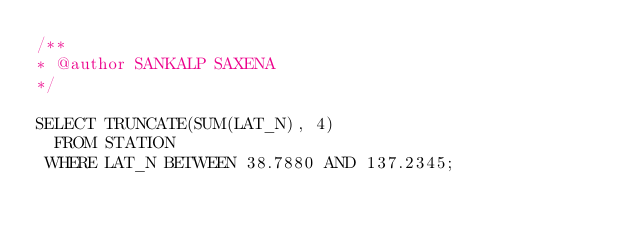Convert code to text. <code><loc_0><loc_0><loc_500><loc_500><_SQL_>/**  
* @author SANKALP SAXENA  
*/

SELECT TRUNCATE(SUM(LAT_N), 4)
  FROM STATION
 WHERE LAT_N BETWEEN 38.7880 AND 137.2345;</code> 